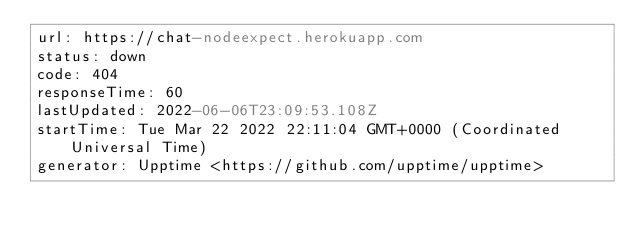Convert code to text. <code><loc_0><loc_0><loc_500><loc_500><_YAML_>url: https://chat-nodeexpect.herokuapp.com
status: down
code: 404
responseTime: 60
lastUpdated: 2022-06-06T23:09:53.108Z
startTime: Tue Mar 22 2022 22:11:04 GMT+0000 (Coordinated Universal Time)
generator: Upptime <https://github.com/upptime/upptime>
</code> 